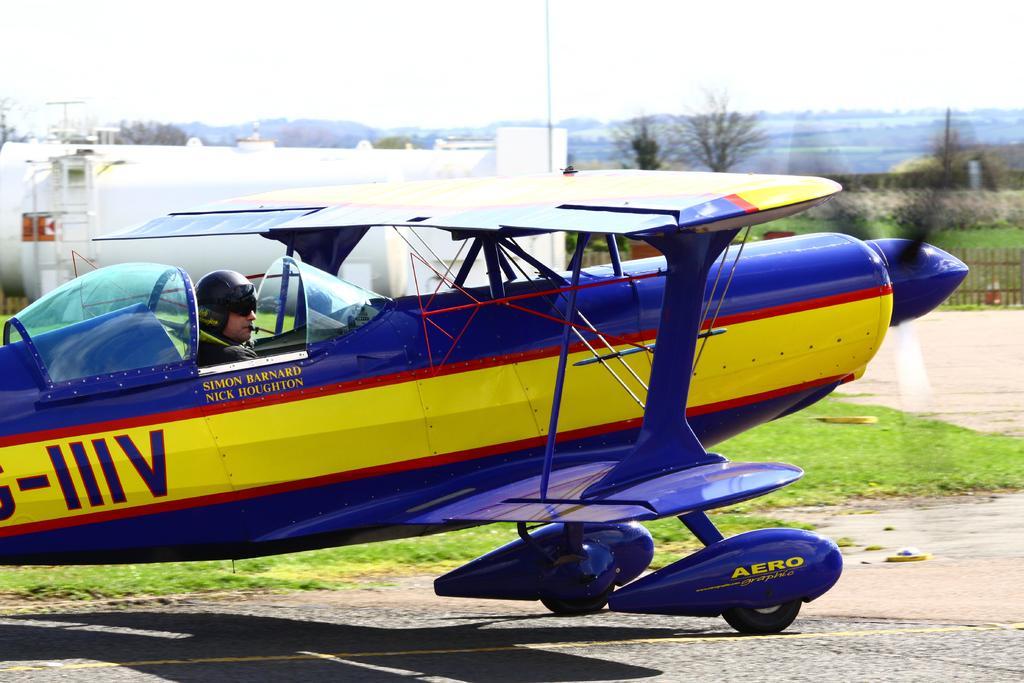How would you summarize this image in a sentence or two? In this image I can see an aircraft on the road and in the aircraft I can see one man is sitting. I can see he is wearing a helmet and on the aircraft I can see something is written. In the background I can see an open grass ground, number of trees, a white colour thing and the sky. On the right side of the image I can see the wooden fencing. 